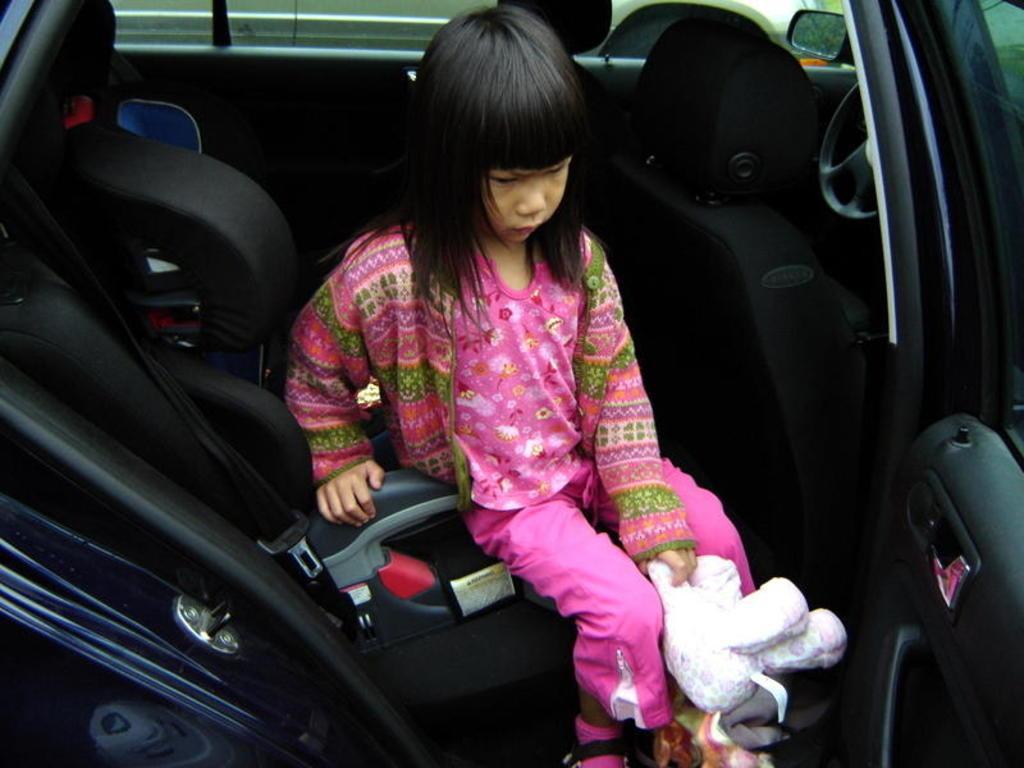Could you give a brief overview of what you see in this image? In this image i can see a girl wearing a pink dress and holding a doll in her hand is sitting in a car. In the background i can see the steering, a window and the side mirror of the car. 